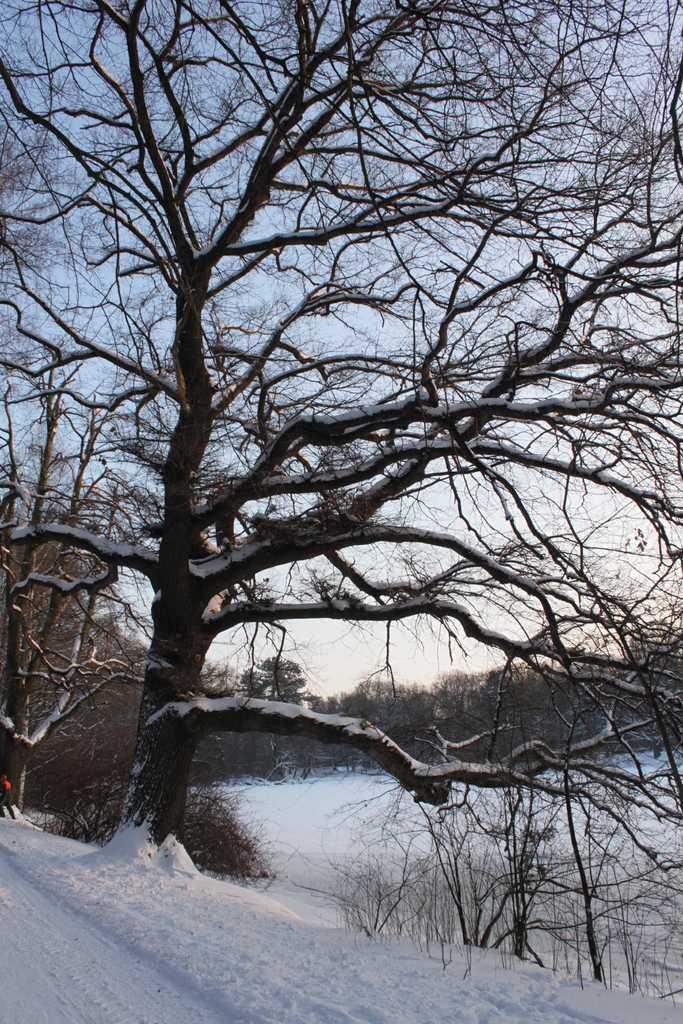Can you describe this image briefly? In this image there are trees. At the bottom there is snow. In the background there is sky. 